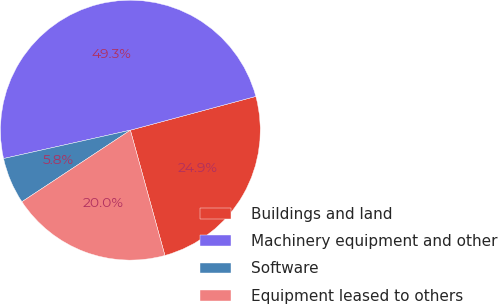Convert chart. <chart><loc_0><loc_0><loc_500><loc_500><pie_chart><fcel>Buildings and land<fcel>Machinery equipment and other<fcel>Software<fcel>Equipment leased to others<nl><fcel>24.9%<fcel>49.32%<fcel>5.78%<fcel>20.0%<nl></chart> 